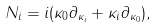Convert formula to latex. <formula><loc_0><loc_0><loc_500><loc_500>N _ { i } = i ( \kappa _ { 0 } \partial _ { \kappa _ { i } } + \kappa _ { i } \partial _ { \kappa _ { 0 } } ) ,</formula> 